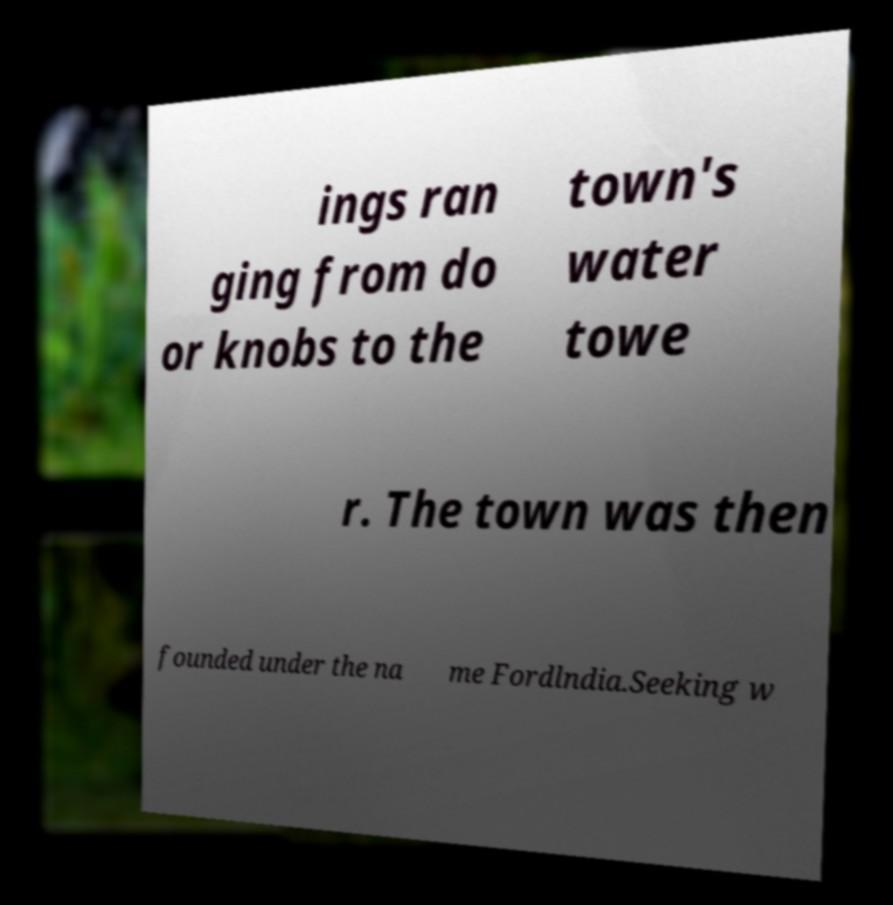What messages or text are displayed in this image? I need them in a readable, typed format. ings ran ging from do or knobs to the town's water towe r. The town was then founded under the na me Fordlndia.Seeking w 